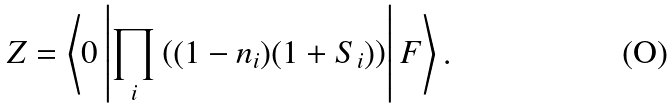<formula> <loc_0><loc_0><loc_500><loc_500>Z = \left \langle 0 \left | \prod _ { i } \left ( ( 1 - n _ { i } ) ( 1 + S _ { i } ) \right ) \right | F \right \rangle .</formula> 